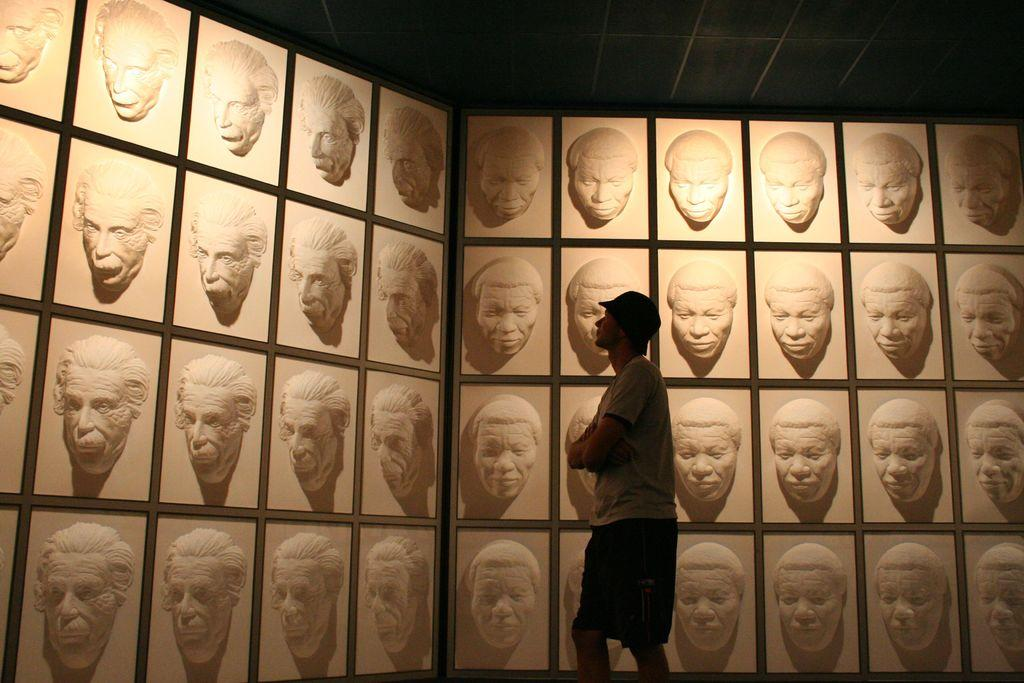Who or what can be seen in the image? There is a person in the image. What can be seen in the background of the image? There is a roof visible in the background of the image. What type of decoration is present on the wall in the background of the image? There are sculptures of people's faces on the wall in the background of the image. What type of quiet celery is being used to decorate the person's hair in the image? There is no celery present in the image, and the person's hair is not being decorated with any type of vegetable. 